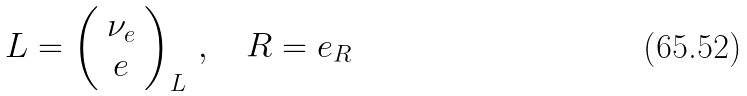<formula> <loc_0><loc_0><loc_500><loc_500>L = \left ( \begin{array} { c } \nu _ { e } \\ e \end{array} \right ) _ { L } \, , \quad R = e _ { R }</formula> 